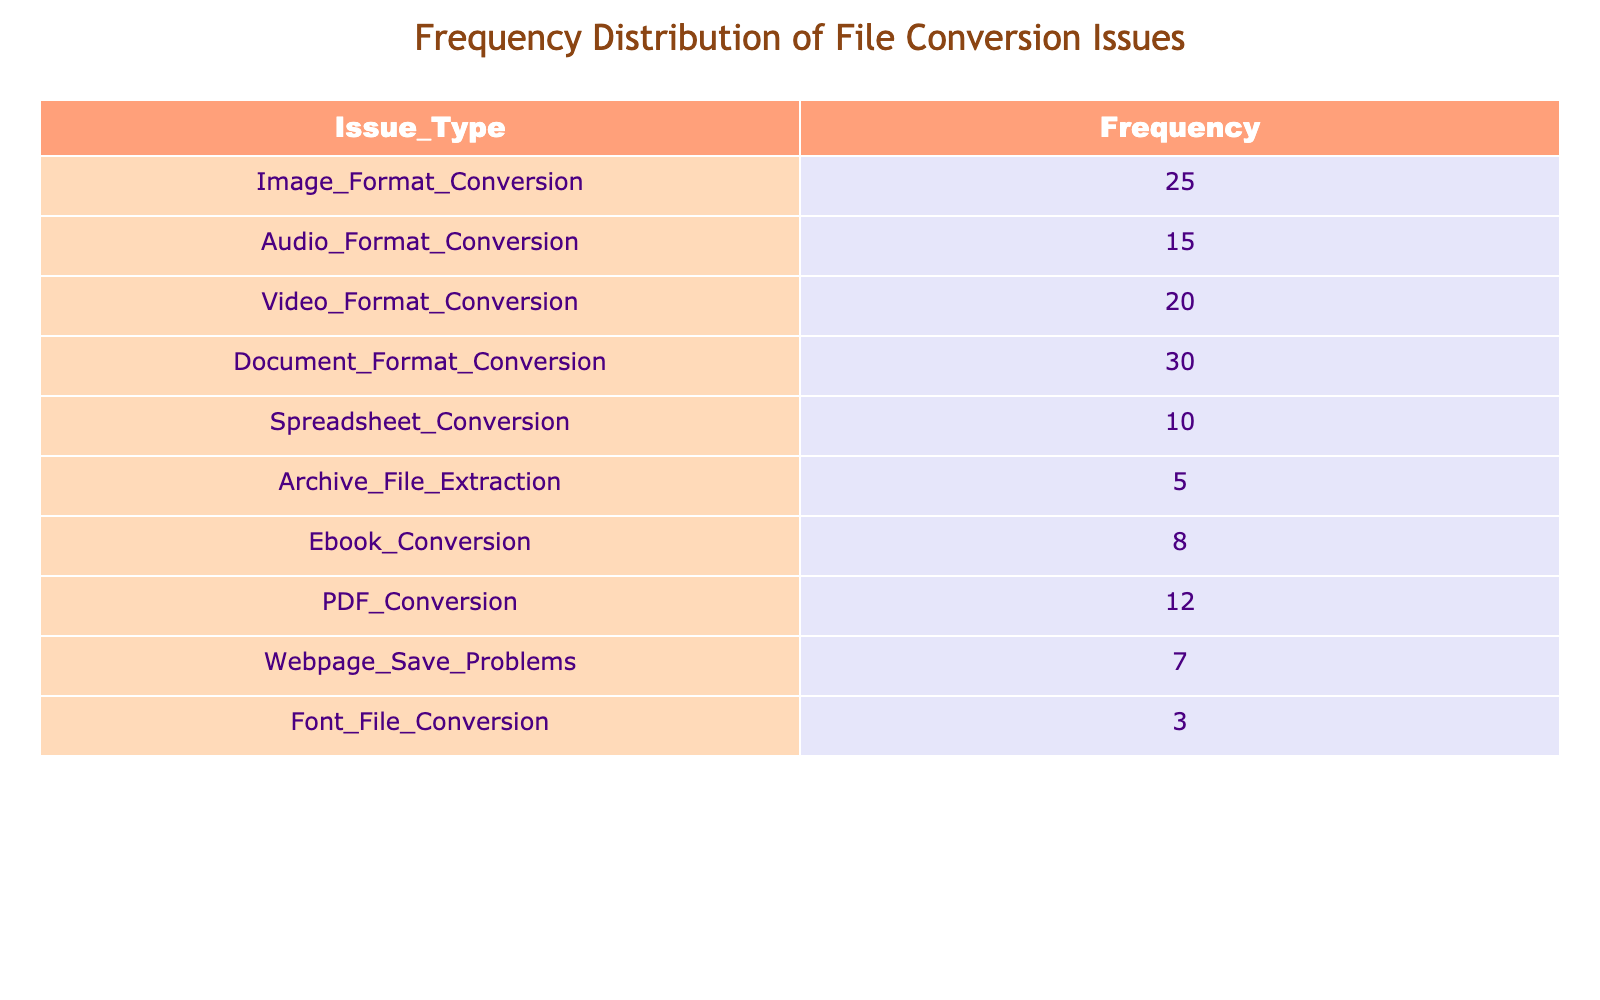What is the frequency of Document Format Conversion issues? The table clearly shows that the frequency for Document Format Conversion is listed as 30.
Answer: 30 Which issue type has the lowest frequency of occurrence? By examining the frequency values, it's evident that Font File Conversion has the lowest frequency, which is 3.
Answer: Font File Conversion What is the total frequency of Image, Audio, and Video Format Conversion issues combined? To find the total, we add the frequencies of these three issues: Image Format Conversion (25) + Audio Format Conversion (15) + Video Format Conversion (20) = 60.
Answer: 60 Is the frequency of Ebook Conversion greater than 10? The frequency for Ebook Conversion is listed as 8 in the table, which is less than 10.
Answer: No What is the average frequency of all the file conversion issues listed? To find the average, we first sum up all frequencies: 25 + 15 + 20 + 30 + 10 + 5 + 8 + 12 + 7 + 3 = 135. There are 10 issue types, so the average is 135 / 10 = 13.5.
Answer: 13.5 How many more reported issues are there for Document Format Conversion compared to Archive File Extraction? Document Format Conversion has a frequency of 30 and Archive File Extraction has a frequency of 5. The difference is 30 - 5 = 25.
Answer: 25 Which two types of conversion issues together have a total frequency of 35? By checking combinations, we find that the frequencies of Document Format Conversion (30) and PDF Conversion (12) do not fit. However, Document Format Conversion (30) and Image Format Conversion (25) together make a total of 55. Hence, the combination should be Spreadsheet Conversion (10) and Webpage Save Problems (7), which totals 17. They do not fit either. None of the combos meet 35 directly, but rather, Document Format (30) is close to needing an addition, should seek to localize.
Answer: None fit exactly to 35 Are there any issue types with a frequency greater than 20? Reviewing the table, the issue types with frequencies greater than 20 are Document Format Conversion (30), Image Format Conversion (25), and Video Format Conversion (20).
Answer: Yes What is the total frequency of all the conversion issues excluding Archive File Extraction? The total excluding Archive File Extraction, which is 5, is calculated as: 135 (total) - 5 = 130. Thus adding the rest gives 130.
Answer: 130 